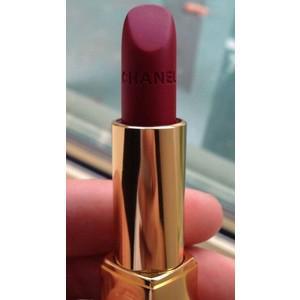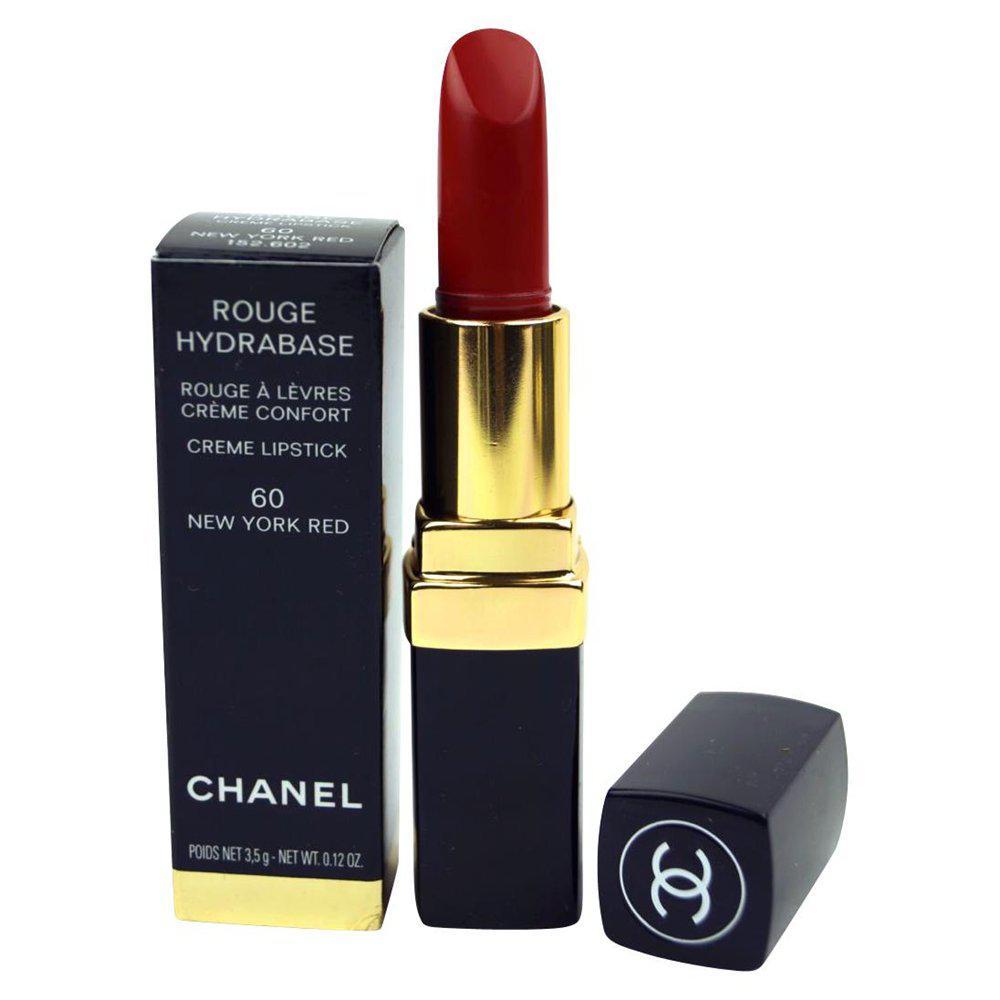The first image is the image on the left, the second image is the image on the right. Analyze the images presented: Is the assertion "One images shows at least five tubes of lipstick with all the caps off lined up in a row." valid? Answer yes or no. No. 